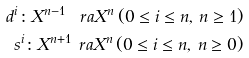Convert formula to latex. <formula><loc_0><loc_0><loc_500><loc_500>d ^ { i } \colon X ^ { n - 1 } \ r a X ^ { n } \, ( 0 \leq i \leq n , \, n \geq 1 ) \\ s ^ { i } \colon X ^ { n + 1 } \ r a X ^ { n } \, ( 0 \leq i \leq n , \, n \geq 0 )</formula> 